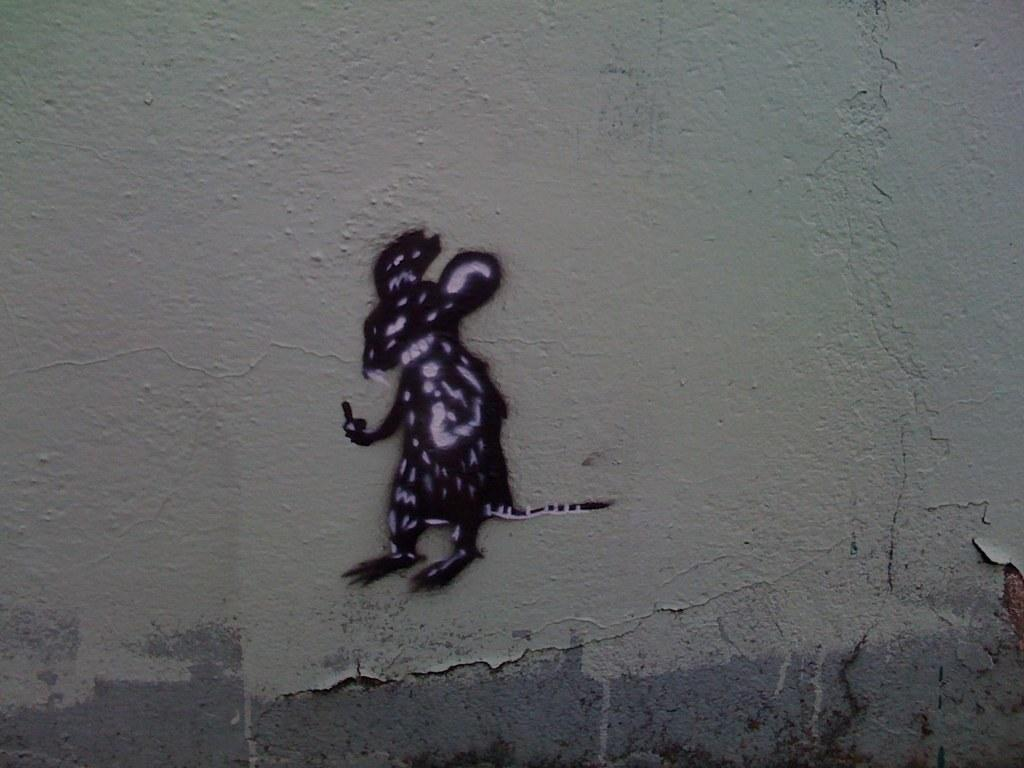What is depicted on the poster that is visible on the wall in the image? There is a rat poster on the wall in the image. What type of creature is shown on the national flag in the image? There is no national flag present in the image, and therefore no creature can be observed on it. 